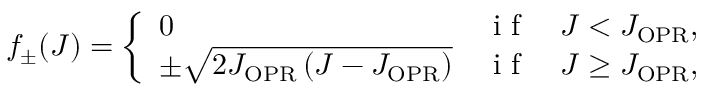Convert formula to latex. <formula><loc_0><loc_0><loc_500><loc_500>f _ { \pm } ( J ) = \left \{ \begin{array} { l l } { 0 } & { i f \quad J < J _ { O P R } , } \\ { \pm \sqrt { 2 J _ { O P R } \left ( J - J _ { O P \mathrm { R } } \right ) } } & { i f \quad J \geq J _ { O P R } , } \end{array}</formula> 